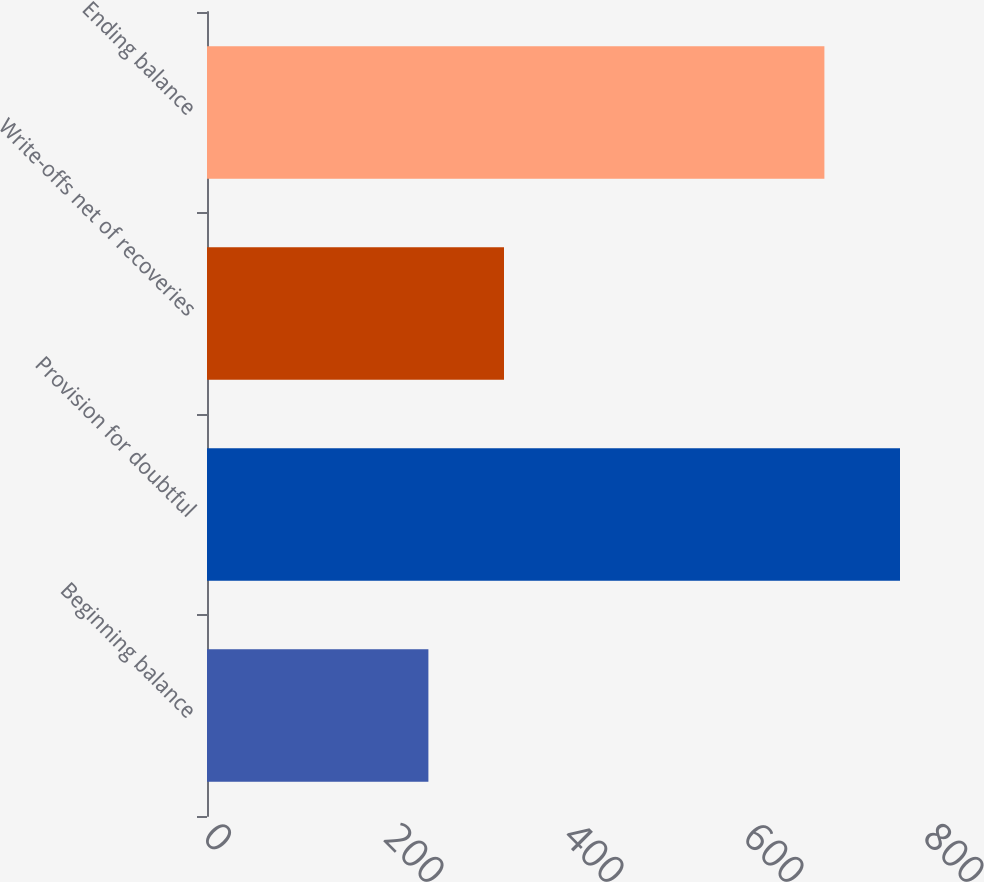<chart> <loc_0><loc_0><loc_500><loc_500><bar_chart><fcel>Beginning balance<fcel>Provision for doubtful<fcel>Write-offs net of recoveries<fcel>Ending balance<nl><fcel>246<fcel>770<fcel>330<fcel>686<nl></chart> 